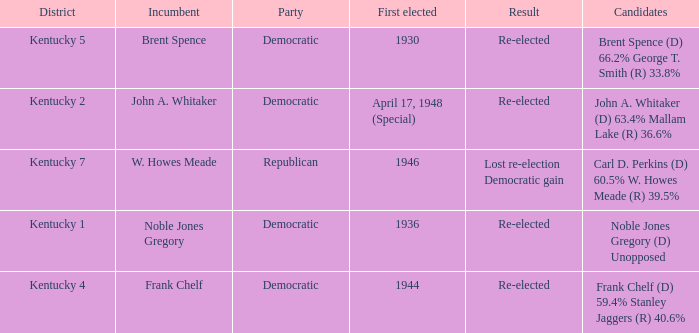What was the result of the election incumbent Brent Spence took place in? Re-elected. 